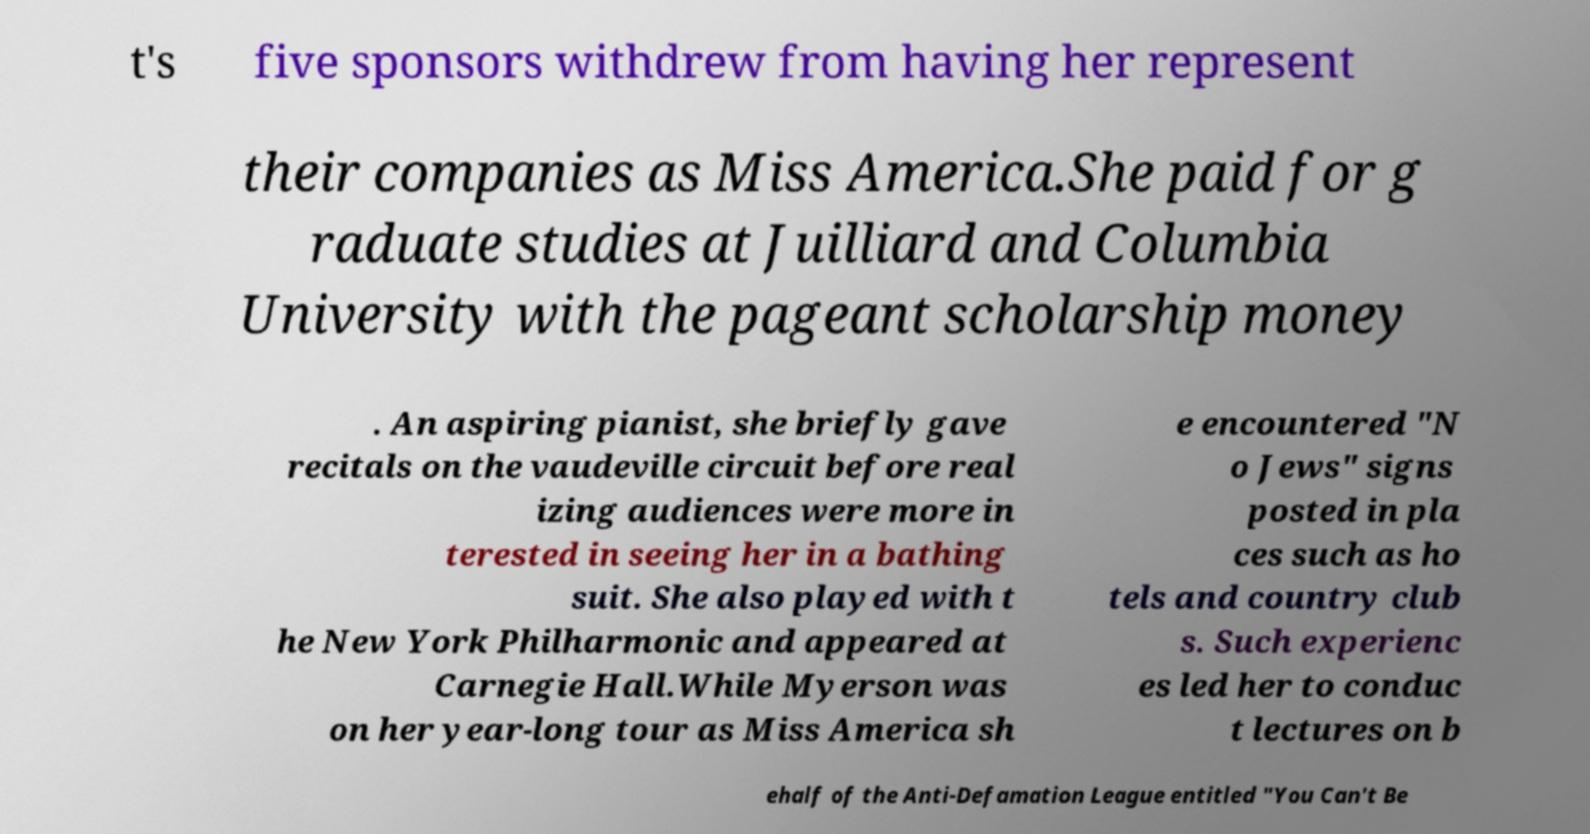Could you extract and type out the text from this image? t's five sponsors withdrew from having her represent their companies as Miss America.She paid for g raduate studies at Juilliard and Columbia University with the pageant scholarship money . An aspiring pianist, she briefly gave recitals on the vaudeville circuit before real izing audiences were more in terested in seeing her in a bathing suit. She also played with t he New York Philharmonic and appeared at Carnegie Hall.While Myerson was on her year-long tour as Miss America sh e encountered "N o Jews" signs posted in pla ces such as ho tels and country club s. Such experienc es led her to conduc t lectures on b ehalf of the Anti-Defamation League entitled "You Can't Be 